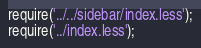Convert code to text. <code><loc_0><loc_0><loc_500><loc_500><_JavaScript_>require('../../sidebar/index.less');
require('../index.less');</code> 